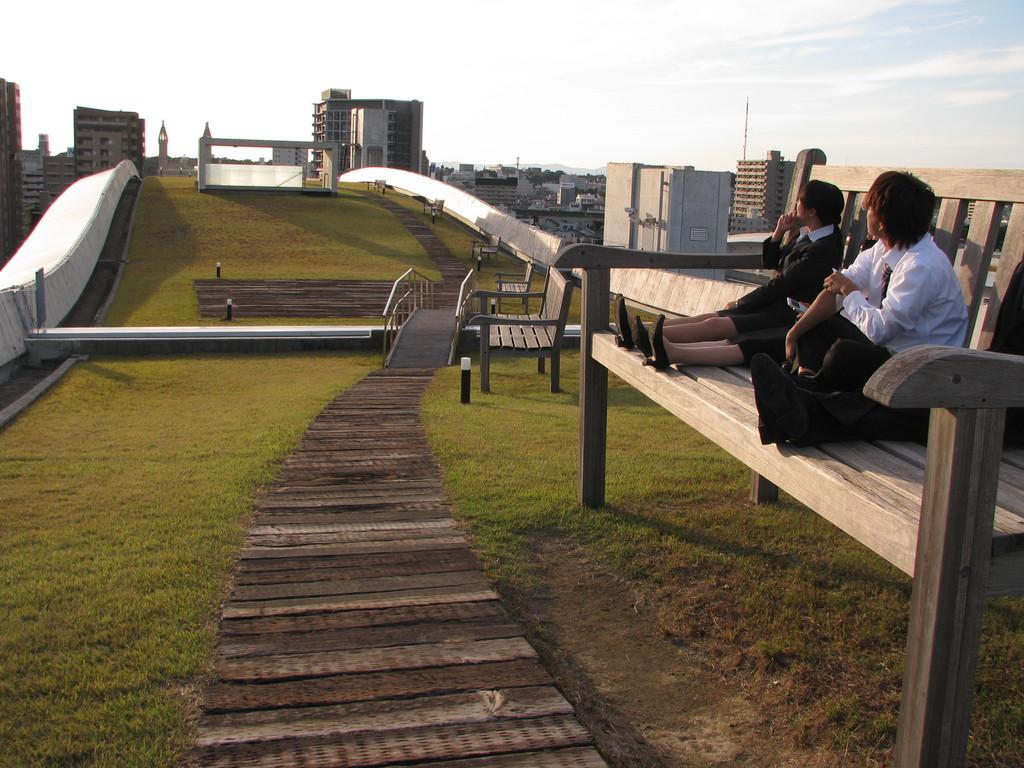Please provide a concise description of this image. In this image, There is a ground of grass, In the right side of the image there is a chair which is in brown color and there are some people siting on the chair, In the background there is a wall of white color and in the middle there is grass and there are some homes and there is sky in white color. 